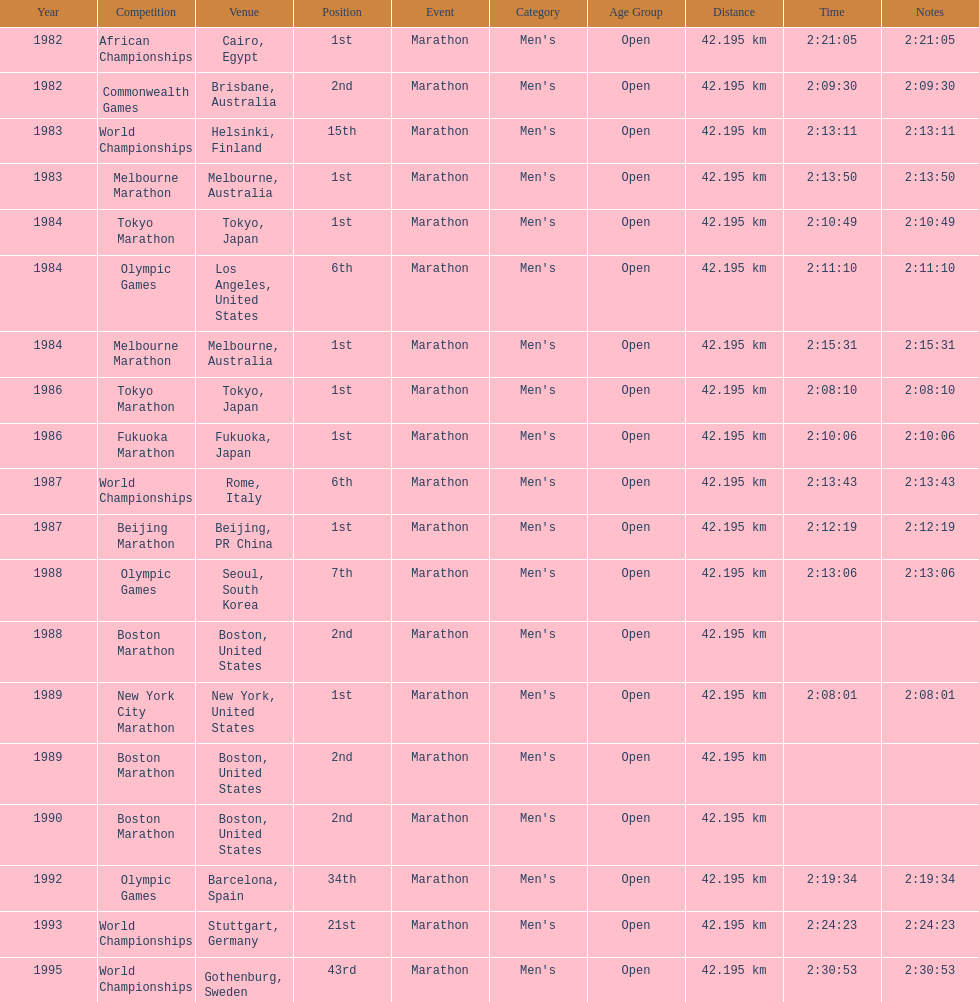In what year did the runner participate in the most marathons? 1984. 